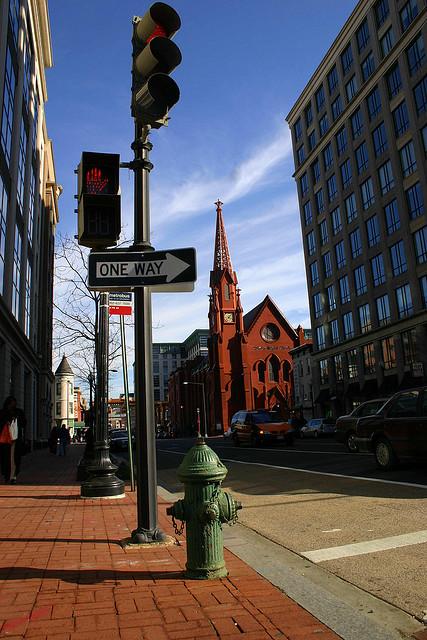Which way is the arrow pointing?
Short answer required. Right. What letter is on the top most sign?
Short answer required. One way. Is this a water pump?
Give a very brief answer. No. What is the purpose of the building with the tall spire?
Give a very brief answer. Church. Is the street clean?
Short answer required. Yes. What is to the left of the hydrant?
Give a very brief answer. Sign. Is this a two-way street?
Be succinct. No. 